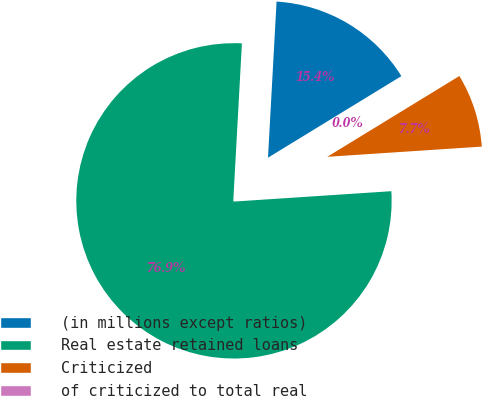Convert chart to OTSL. <chart><loc_0><loc_0><loc_500><loc_500><pie_chart><fcel>(in millions except ratios)<fcel>Real estate retained loans<fcel>Criticized<fcel>of criticized to total real<nl><fcel>15.39%<fcel>76.92%<fcel>7.69%<fcel>0.0%<nl></chart> 